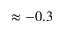Convert formula to latex. <formula><loc_0><loc_0><loc_500><loc_500>\approx - 0 . 3</formula> 